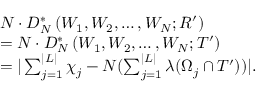Convert formula to latex. <formula><loc_0><loc_0><loc_500><loc_500>\begin{array} { r l } & { N \cdot D _ { N } ^ { * } \left ( W _ { 1 } , W _ { 2 } , \dots , W _ { N } ; R ^ { \prime } \right ) } \\ & { = N \cdot D _ { N } ^ { * } \left ( W _ { 1 } , W _ { 2 } , \dots , W _ { N } ; T ^ { \prime } \right ) } \\ & { = | \sum _ { j = 1 } ^ { | L | } \chi _ { j } - N ( \sum _ { j = 1 } ^ { | L | } \lambda ( \Omega _ { j } \cap T ^ { \prime } ) ) | . } \end{array}</formula> 